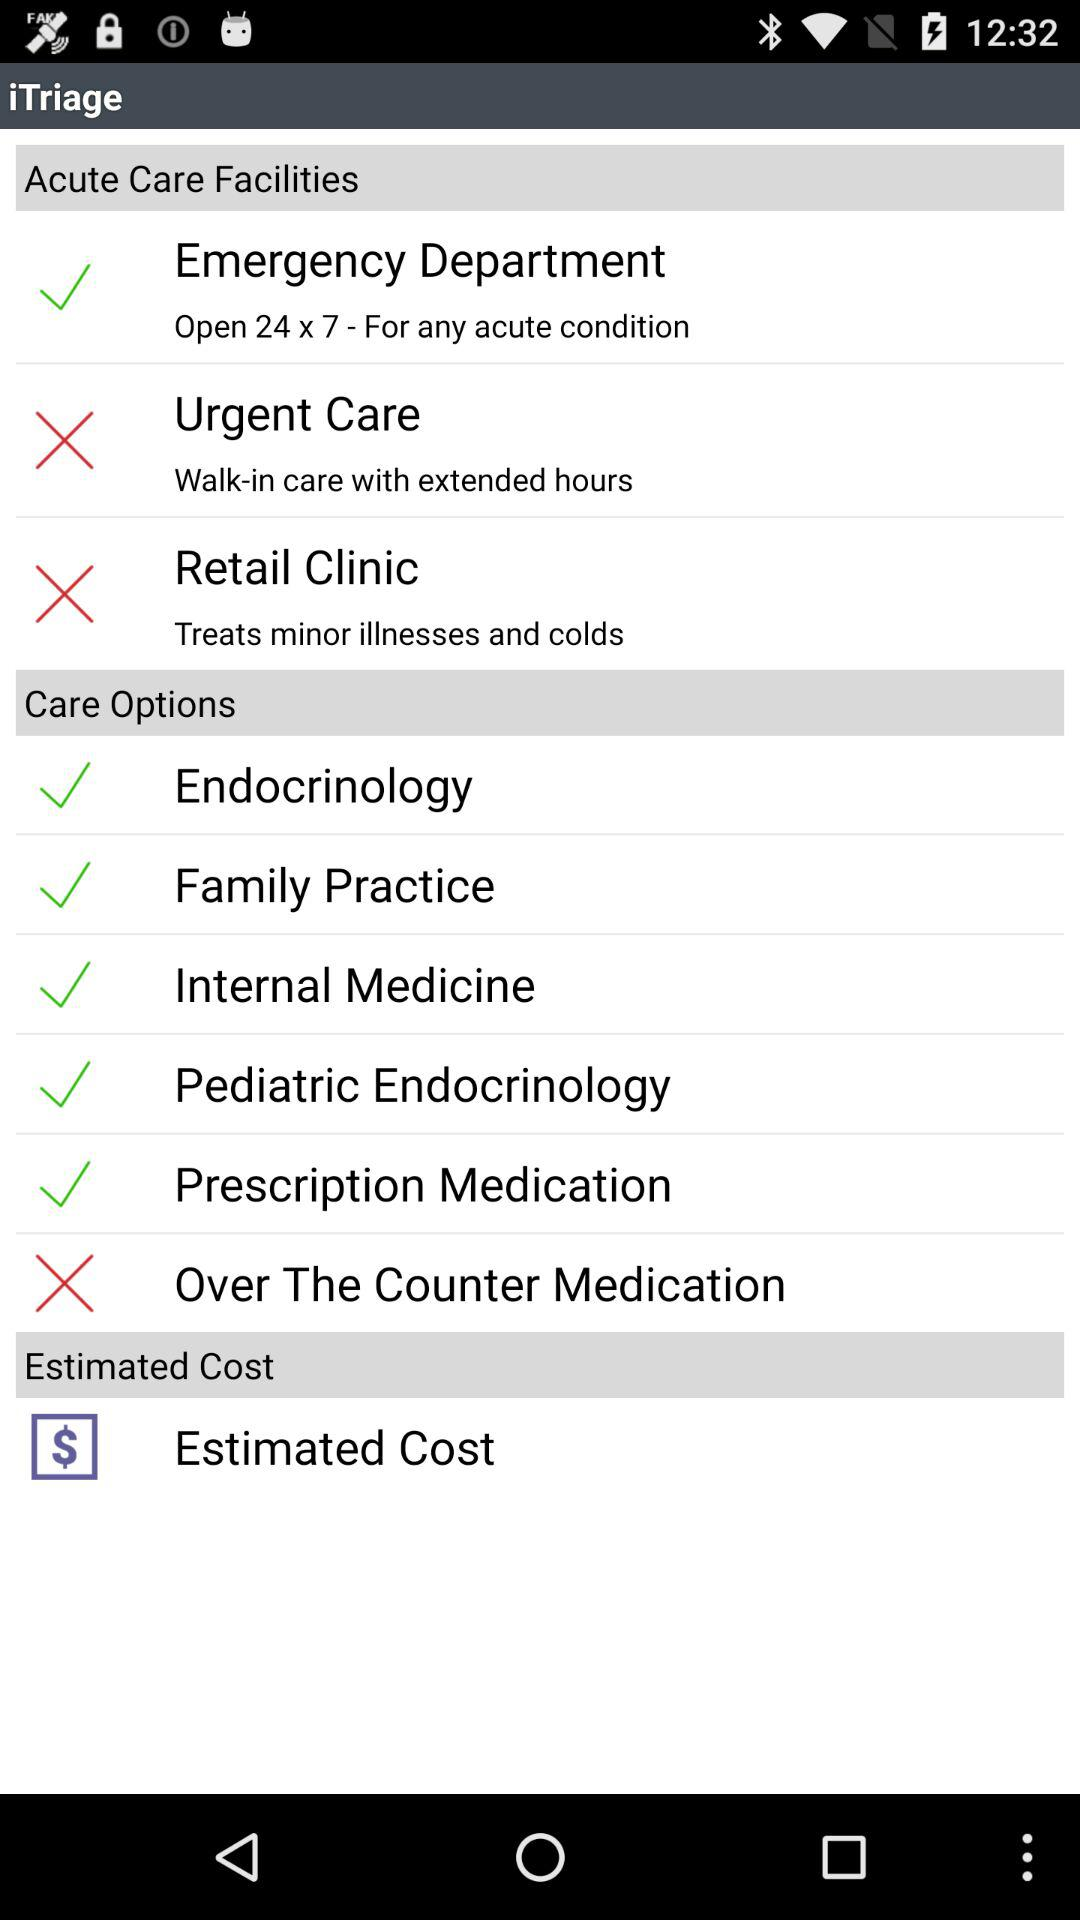What option is selected in "Care Options"? The selected options in "Care Options" are "Endocrinology", "Family Practice", "Internal Medicine", "Pediatric Endocrinology" and "Prescription Medication". 